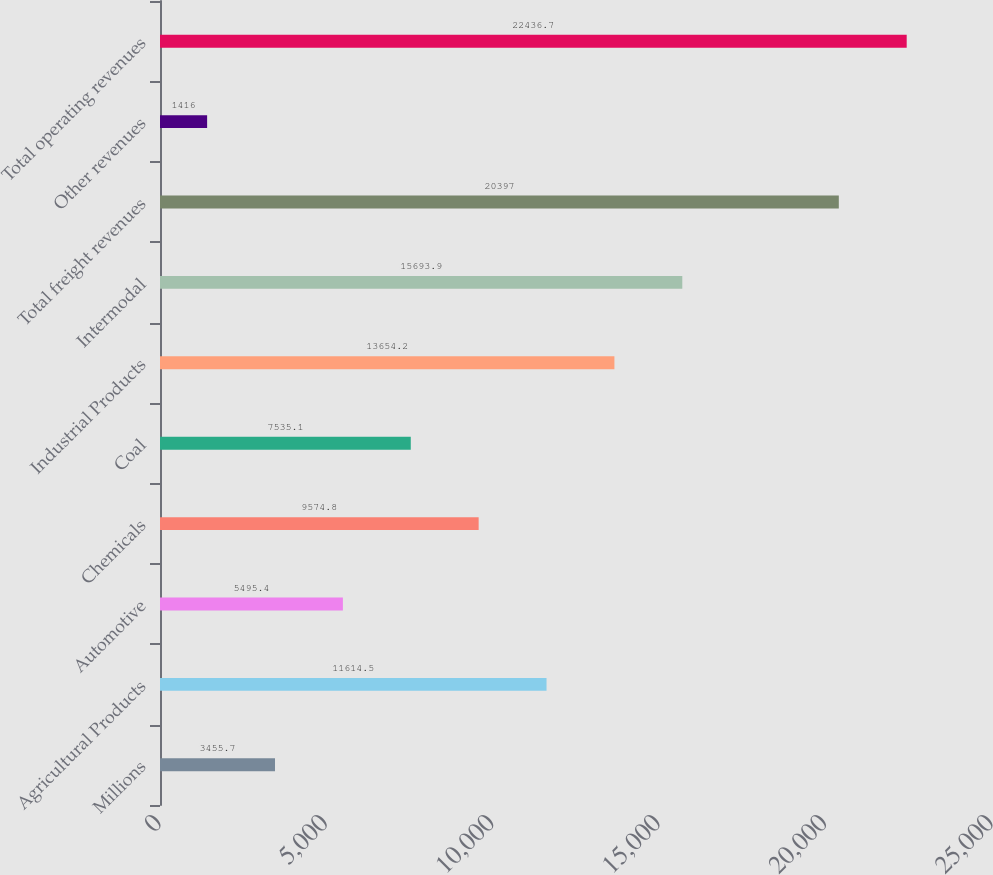<chart> <loc_0><loc_0><loc_500><loc_500><bar_chart><fcel>Millions<fcel>Agricultural Products<fcel>Automotive<fcel>Chemicals<fcel>Coal<fcel>Industrial Products<fcel>Intermodal<fcel>Total freight revenues<fcel>Other revenues<fcel>Total operating revenues<nl><fcel>3455.7<fcel>11614.5<fcel>5495.4<fcel>9574.8<fcel>7535.1<fcel>13654.2<fcel>15693.9<fcel>20397<fcel>1416<fcel>22436.7<nl></chart> 